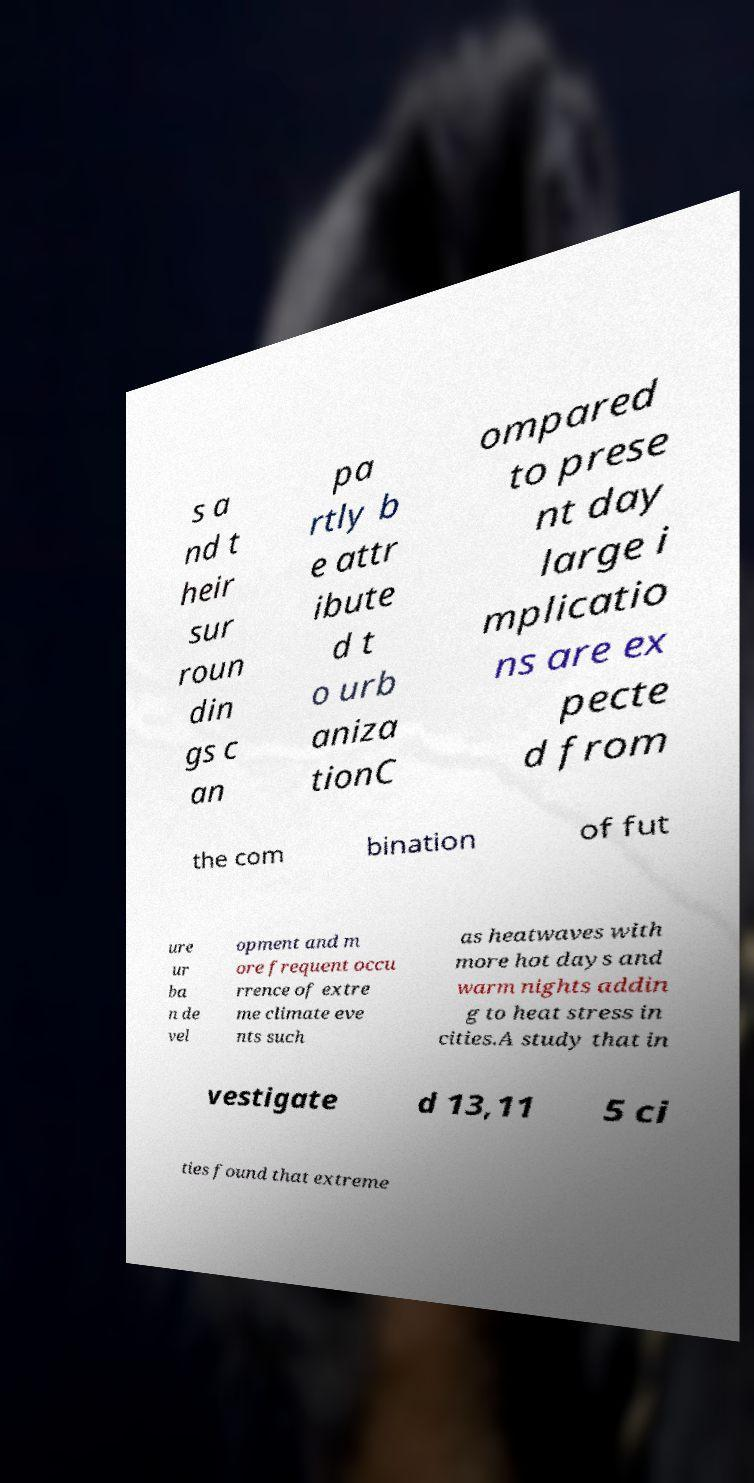There's text embedded in this image that I need extracted. Can you transcribe it verbatim? s a nd t heir sur roun din gs c an pa rtly b e attr ibute d t o urb aniza tionC ompared to prese nt day large i mplicatio ns are ex pecte d from the com bination of fut ure ur ba n de vel opment and m ore frequent occu rrence of extre me climate eve nts such as heatwaves with more hot days and warm nights addin g to heat stress in cities.A study that in vestigate d 13,11 5 ci ties found that extreme 